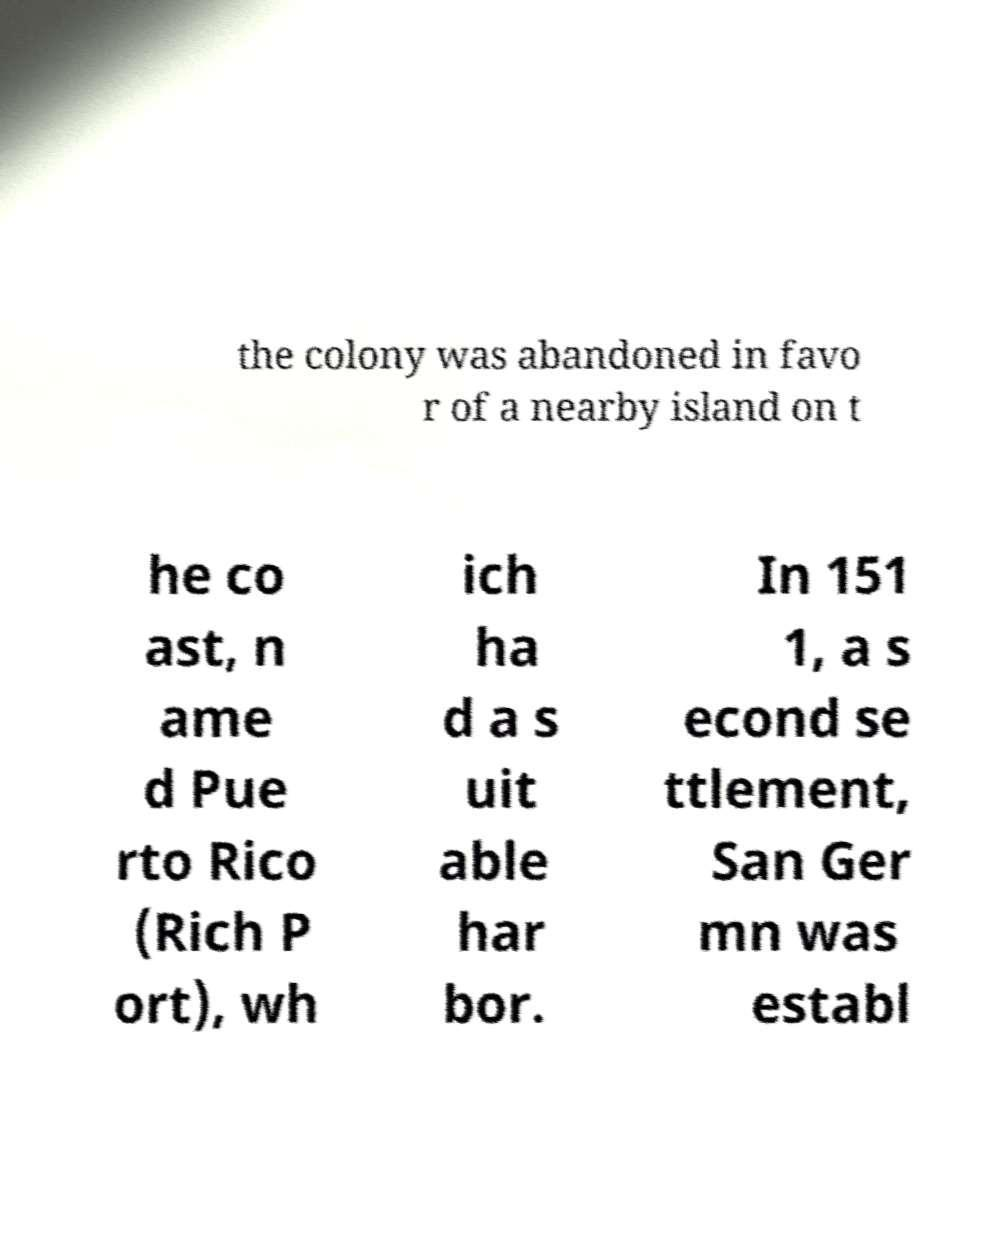Can you read and provide the text displayed in the image?This photo seems to have some interesting text. Can you extract and type it out for me? the colony was abandoned in favo r of a nearby island on t he co ast, n ame d Pue rto Rico (Rich P ort), wh ich ha d a s uit able har bor. In 151 1, a s econd se ttlement, San Ger mn was establ 